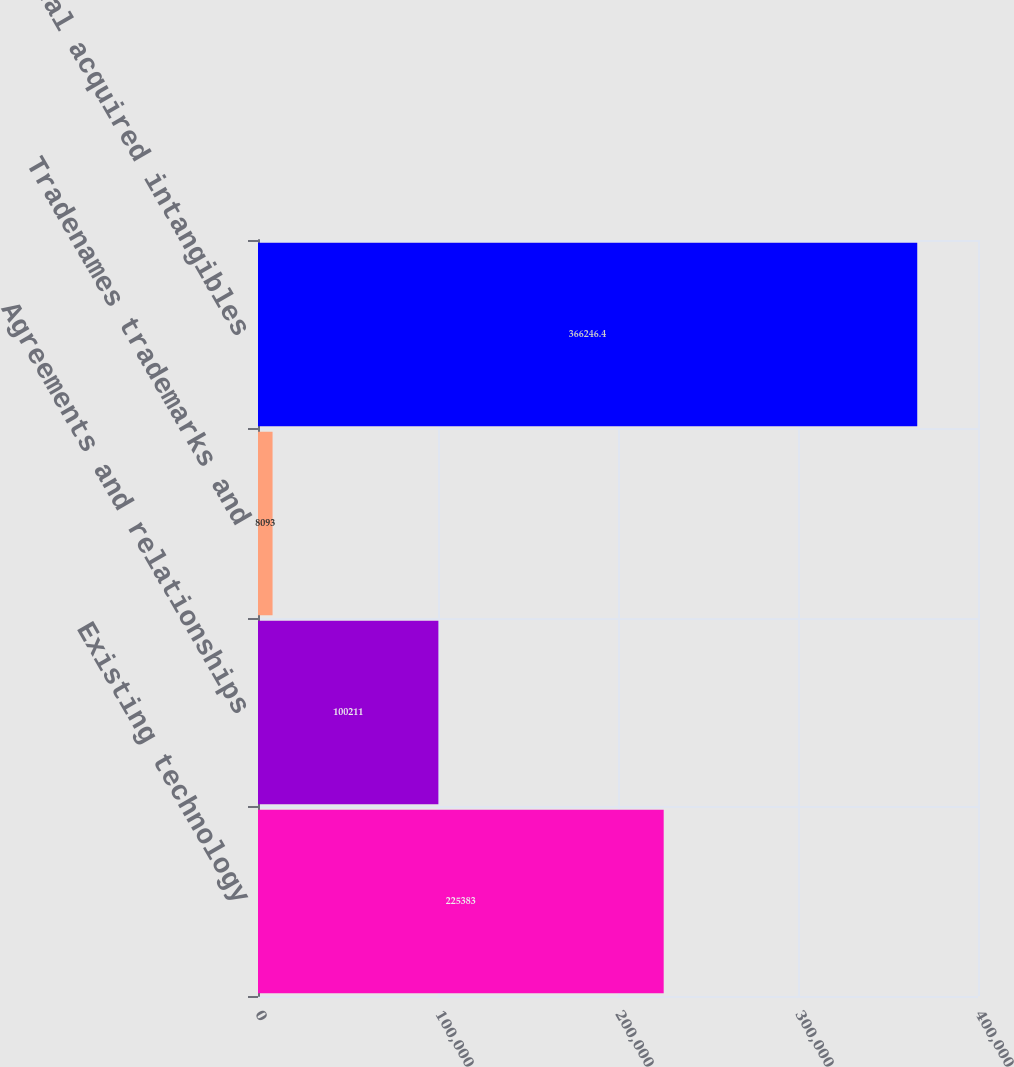Convert chart to OTSL. <chart><loc_0><loc_0><loc_500><loc_500><bar_chart><fcel>Existing technology<fcel>Agreements and relationships<fcel>Tradenames trademarks and<fcel>Total acquired intangibles<nl><fcel>225383<fcel>100211<fcel>8093<fcel>366246<nl></chart> 